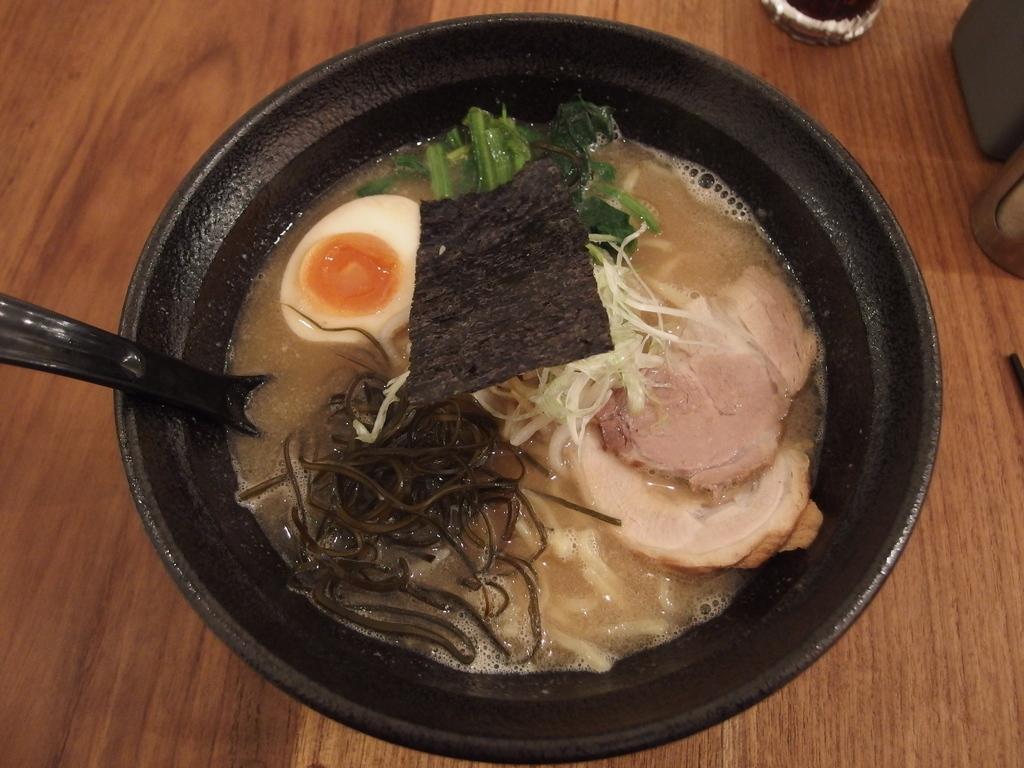Describe this image in one or two sentences. In this image I can see a bowl kept on the table, on the bowl I can see a food stuff and table. 